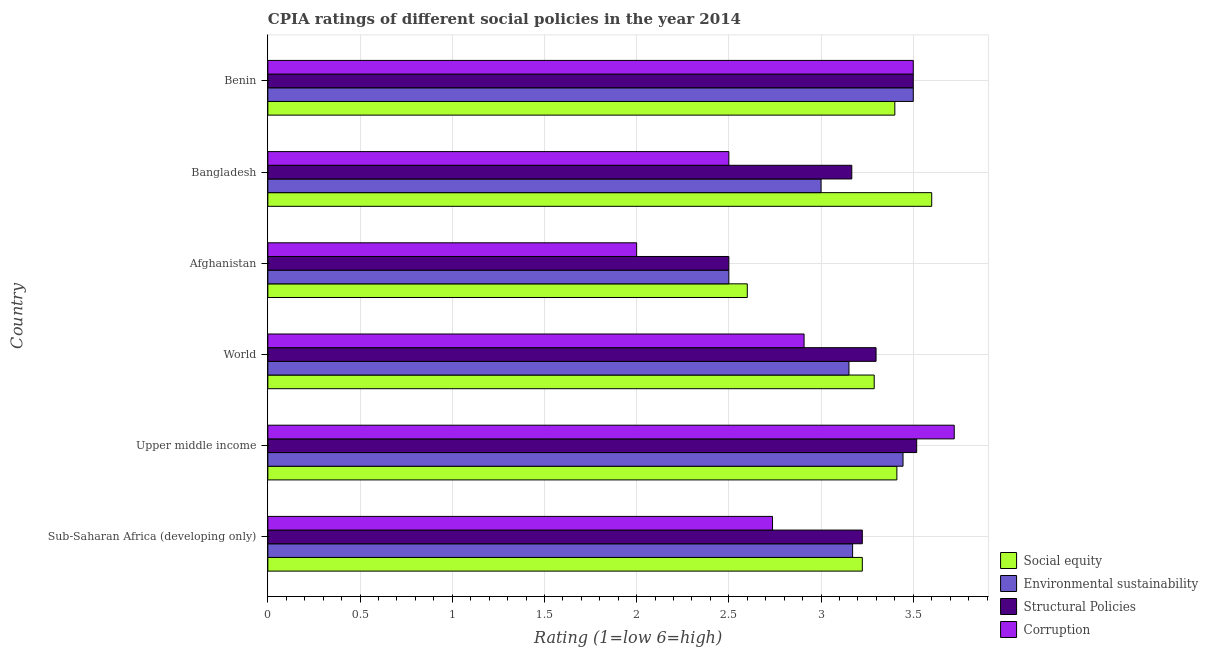How many different coloured bars are there?
Offer a very short reply. 4. What is the label of the 4th group of bars from the top?
Provide a short and direct response. World. What is the cpia rating of environmental sustainability in Sub-Saharan Africa (developing only)?
Make the answer very short. 3.17. Across all countries, what is the maximum cpia rating of social equity?
Keep it short and to the point. 3.6. In which country was the cpia rating of structural policies maximum?
Make the answer very short. Upper middle income. In which country was the cpia rating of social equity minimum?
Your answer should be compact. Afghanistan. What is the total cpia rating of structural policies in the graph?
Give a very brief answer. 19.21. What is the difference between the cpia rating of environmental sustainability in Afghanistan and that in Benin?
Your answer should be compact. -1. What is the difference between the cpia rating of environmental sustainability in World and the cpia rating of social equity in Sub-Saharan Africa (developing only)?
Keep it short and to the point. -0.07. What is the average cpia rating of structural policies per country?
Offer a very short reply. 3.2. What is the ratio of the cpia rating of environmental sustainability in Bangladesh to that in Upper middle income?
Your answer should be compact. 0.87. Is the cpia rating of environmental sustainability in Benin less than that in Upper middle income?
Give a very brief answer. No. What is the difference between the highest and the second highest cpia rating of environmental sustainability?
Offer a very short reply. 0.06. What is the difference between the highest and the lowest cpia rating of environmental sustainability?
Give a very brief answer. 1. In how many countries, is the cpia rating of environmental sustainability greater than the average cpia rating of environmental sustainability taken over all countries?
Make the answer very short. 4. Is it the case that in every country, the sum of the cpia rating of structural policies and cpia rating of corruption is greater than the sum of cpia rating of social equity and cpia rating of environmental sustainability?
Your answer should be very brief. No. What does the 4th bar from the top in Sub-Saharan Africa (developing only) represents?
Ensure brevity in your answer.  Social equity. What does the 2nd bar from the bottom in World represents?
Ensure brevity in your answer.  Environmental sustainability. Is it the case that in every country, the sum of the cpia rating of social equity and cpia rating of environmental sustainability is greater than the cpia rating of structural policies?
Keep it short and to the point. Yes. Does the graph contain any zero values?
Your answer should be compact. No. Where does the legend appear in the graph?
Your answer should be compact. Bottom right. How many legend labels are there?
Your answer should be very brief. 4. What is the title of the graph?
Give a very brief answer. CPIA ratings of different social policies in the year 2014. What is the Rating (1=low 6=high) of Social equity in Sub-Saharan Africa (developing only)?
Your response must be concise. 3.22. What is the Rating (1=low 6=high) in Environmental sustainability in Sub-Saharan Africa (developing only)?
Give a very brief answer. 3.17. What is the Rating (1=low 6=high) of Structural Policies in Sub-Saharan Africa (developing only)?
Your answer should be very brief. 3.22. What is the Rating (1=low 6=high) of Corruption in Sub-Saharan Africa (developing only)?
Ensure brevity in your answer.  2.74. What is the Rating (1=low 6=high) in Social equity in Upper middle income?
Your answer should be compact. 3.41. What is the Rating (1=low 6=high) of Environmental sustainability in Upper middle income?
Offer a very short reply. 3.44. What is the Rating (1=low 6=high) of Structural Policies in Upper middle income?
Offer a very short reply. 3.52. What is the Rating (1=low 6=high) of Corruption in Upper middle income?
Ensure brevity in your answer.  3.72. What is the Rating (1=low 6=high) of Social equity in World?
Your answer should be very brief. 3.29. What is the Rating (1=low 6=high) in Environmental sustainability in World?
Keep it short and to the point. 3.15. What is the Rating (1=low 6=high) of Structural Policies in World?
Provide a short and direct response. 3.3. What is the Rating (1=low 6=high) of Corruption in World?
Ensure brevity in your answer.  2.91. What is the Rating (1=low 6=high) of Social equity in Afghanistan?
Your answer should be compact. 2.6. What is the Rating (1=low 6=high) of Corruption in Afghanistan?
Provide a short and direct response. 2. What is the Rating (1=low 6=high) in Social equity in Bangladesh?
Your response must be concise. 3.6. What is the Rating (1=low 6=high) in Environmental sustainability in Bangladesh?
Your response must be concise. 3. What is the Rating (1=low 6=high) in Structural Policies in Bangladesh?
Provide a succinct answer. 3.17. What is the Rating (1=low 6=high) of Environmental sustainability in Benin?
Your response must be concise. 3.5. What is the Rating (1=low 6=high) of Structural Policies in Benin?
Your response must be concise. 3.5. What is the Rating (1=low 6=high) in Corruption in Benin?
Make the answer very short. 3.5. Across all countries, what is the maximum Rating (1=low 6=high) in Structural Policies?
Offer a terse response. 3.52. Across all countries, what is the maximum Rating (1=low 6=high) of Corruption?
Ensure brevity in your answer.  3.72. Across all countries, what is the minimum Rating (1=low 6=high) of Social equity?
Give a very brief answer. 2.6. Across all countries, what is the minimum Rating (1=low 6=high) in Environmental sustainability?
Give a very brief answer. 2.5. Across all countries, what is the minimum Rating (1=low 6=high) in Corruption?
Ensure brevity in your answer.  2. What is the total Rating (1=low 6=high) in Social equity in the graph?
Ensure brevity in your answer.  19.52. What is the total Rating (1=low 6=high) in Environmental sustainability in the graph?
Give a very brief answer. 18.77. What is the total Rating (1=low 6=high) of Structural Policies in the graph?
Your answer should be very brief. 19.21. What is the total Rating (1=low 6=high) in Corruption in the graph?
Give a very brief answer. 17.37. What is the difference between the Rating (1=low 6=high) of Social equity in Sub-Saharan Africa (developing only) and that in Upper middle income?
Your answer should be compact. -0.19. What is the difference between the Rating (1=low 6=high) of Environmental sustainability in Sub-Saharan Africa (developing only) and that in Upper middle income?
Your answer should be very brief. -0.27. What is the difference between the Rating (1=low 6=high) in Structural Policies in Sub-Saharan Africa (developing only) and that in Upper middle income?
Provide a short and direct response. -0.29. What is the difference between the Rating (1=low 6=high) in Corruption in Sub-Saharan Africa (developing only) and that in Upper middle income?
Keep it short and to the point. -0.99. What is the difference between the Rating (1=low 6=high) in Social equity in Sub-Saharan Africa (developing only) and that in World?
Provide a succinct answer. -0.06. What is the difference between the Rating (1=low 6=high) of Environmental sustainability in Sub-Saharan Africa (developing only) and that in World?
Your answer should be compact. 0.02. What is the difference between the Rating (1=low 6=high) of Structural Policies in Sub-Saharan Africa (developing only) and that in World?
Keep it short and to the point. -0.07. What is the difference between the Rating (1=low 6=high) of Corruption in Sub-Saharan Africa (developing only) and that in World?
Give a very brief answer. -0.17. What is the difference between the Rating (1=low 6=high) of Social equity in Sub-Saharan Africa (developing only) and that in Afghanistan?
Your answer should be compact. 0.62. What is the difference between the Rating (1=low 6=high) in Environmental sustainability in Sub-Saharan Africa (developing only) and that in Afghanistan?
Offer a terse response. 0.67. What is the difference between the Rating (1=low 6=high) of Structural Policies in Sub-Saharan Africa (developing only) and that in Afghanistan?
Give a very brief answer. 0.72. What is the difference between the Rating (1=low 6=high) of Corruption in Sub-Saharan Africa (developing only) and that in Afghanistan?
Ensure brevity in your answer.  0.74. What is the difference between the Rating (1=low 6=high) in Social equity in Sub-Saharan Africa (developing only) and that in Bangladesh?
Make the answer very short. -0.38. What is the difference between the Rating (1=low 6=high) of Environmental sustainability in Sub-Saharan Africa (developing only) and that in Bangladesh?
Your response must be concise. 0.17. What is the difference between the Rating (1=low 6=high) of Structural Policies in Sub-Saharan Africa (developing only) and that in Bangladesh?
Your answer should be very brief. 0.06. What is the difference between the Rating (1=low 6=high) in Corruption in Sub-Saharan Africa (developing only) and that in Bangladesh?
Provide a succinct answer. 0.24. What is the difference between the Rating (1=low 6=high) in Social equity in Sub-Saharan Africa (developing only) and that in Benin?
Your answer should be compact. -0.18. What is the difference between the Rating (1=low 6=high) of Environmental sustainability in Sub-Saharan Africa (developing only) and that in Benin?
Your response must be concise. -0.33. What is the difference between the Rating (1=low 6=high) in Structural Policies in Sub-Saharan Africa (developing only) and that in Benin?
Your answer should be very brief. -0.28. What is the difference between the Rating (1=low 6=high) in Corruption in Sub-Saharan Africa (developing only) and that in Benin?
Your response must be concise. -0.76. What is the difference between the Rating (1=low 6=high) of Social equity in Upper middle income and that in World?
Provide a succinct answer. 0.12. What is the difference between the Rating (1=low 6=high) in Environmental sustainability in Upper middle income and that in World?
Offer a very short reply. 0.29. What is the difference between the Rating (1=low 6=high) of Structural Policies in Upper middle income and that in World?
Offer a very short reply. 0.22. What is the difference between the Rating (1=low 6=high) of Corruption in Upper middle income and that in World?
Your answer should be compact. 0.81. What is the difference between the Rating (1=low 6=high) of Social equity in Upper middle income and that in Afghanistan?
Keep it short and to the point. 0.81. What is the difference between the Rating (1=low 6=high) in Environmental sustainability in Upper middle income and that in Afghanistan?
Ensure brevity in your answer.  0.94. What is the difference between the Rating (1=low 6=high) in Structural Policies in Upper middle income and that in Afghanistan?
Keep it short and to the point. 1.02. What is the difference between the Rating (1=low 6=high) of Corruption in Upper middle income and that in Afghanistan?
Give a very brief answer. 1.72. What is the difference between the Rating (1=low 6=high) of Social equity in Upper middle income and that in Bangladesh?
Your answer should be compact. -0.19. What is the difference between the Rating (1=low 6=high) in Environmental sustainability in Upper middle income and that in Bangladesh?
Offer a terse response. 0.44. What is the difference between the Rating (1=low 6=high) of Structural Policies in Upper middle income and that in Bangladesh?
Offer a terse response. 0.35. What is the difference between the Rating (1=low 6=high) of Corruption in Upper middle income and that in Bangladesh?
Your answer should be compact. 1.22. What is the difference between the Rating (1=low 6=high) of Social equity in Upper middle income and that in Benin?
Keep it short and to the point. 0.01. What is the difference between the Rating (1=low 6=high) in Environmental sustainability in Upper middle income and that in Benin?
Provide a succinct answer. -0.06. What is the difference between the Rating (1=low 6=high) of Structural Policies in Upper middle income and that in Benin?
Provide a short and direct response. 0.02. What is the difference between the Rating (1=low 6=high) of Corruption in Upper middle income and that in Benin?
Your answer should be compact. 0.22. What is the difference between the Rating (1=low 6=high) of Social equity in World and that in Afghanistan?
Your answer should be compact. 0.69. What is the difference between the Rating (1=low 6=high) of Environmental sustainability in World and that in Afghanistan?
Offer a terse response. 0.65. What is the difference between the Rating (1=low 6=high) in Structural Policies in World and that in Afghanistan?
Offer a very short reply. 0.8. What is the difference between the Rating (1=low 6=high) in Corruption in World and that in Afghanistan?
Make the answer very short. 0.91. What is the difference between the Rating (1=low 6=high) in Social equity in World and that in Bangladesh?
Make the answer very short. -0.31. What is the difference between the Rating (1=low 6=high) of Environmental sustainability in World and that in Bangladesh?
Make the answer very short. 0.15. What is the difference between the Rating (1=low 6=high) in Structural Policies in World and that in Bangladesh?
Ensure brevity in your answer.  0.13. What is the difference between the Rating (1=low 6=high) of Corruption in World and that in Bangladesh?
Ensure brevity in your answer.  0.41. What is the difference between the Rating (1=low 6=high) of Social equity in World and that in Benin?
Offer a very short reply. -0.11. What is the difference between the Rating (1=low 6=high) in Environmental sustainability in World and that in Benin?
Keep it short and to the point. -0.35. What is the difference between the Rating (1=low 6=high) in Structural Policies in World and that in Benin?
Your response must be concise. -0.2. What is the difference between the Rating (1=low 6=high) of Corruption in World and that in Benin?
Your response must be concise. -0.59. What is the difference between the Rating (1=low 6=high) in Social equity in Afghanistan and that in Bangladesh?
Offer a terse response. -1. What is the difference between the Rating (1=low 6=high) of Corruption in Afghanistan and that in Bangladesh?
Provide a short and direct response. -0.5. What is the difference between the Rating (1=low 6=high) of Social equity in Afghanistan and that in Benin?
Offer a very short reply. -0.8. What is the difference between the Rating (1=low 6=high) of Social equity in Bangladesh and that in Benin?
Provide a succinct answer. 0.2. What is the difference between the Rating (1=low 6=high) in Environmental sustainability in Bangladesh and that in Benin?
Your answer should be compact. -0.5. What is the difference between the Rating (1=low 6=high) in Corruption in Bangladesh and that in Benin?
Provide a succinct answer. -1. What is the difference between the Rating (1=low 6=high) in Social equity in Sub-Saharan Africa (developing only) and the Rating (1=low 6=high) in Environmental sustainability in Upper middle income?
Offer a terse response. -0.22. What is the difference between the Rating (1=low 6=high) of Social equity in Sub-Saharan Africa (developing only) and the Rating (1=low 6=high) of Structural Policies in Upper middle income?
Make the answer very short. -0.29. What is the difference between the Rating (1=low 6=high) of Social equity in Sub-Saharan Africa (developing only) and the Rating (1=low 6=high) of Corruption in Upper middle income?
Offer a terse response. -0.5. What is the difference between the Rating (1=low 6=high) of Environmental sustainability in Sub-Saharan Africa (developing only) and the Rating (1=low 6=high) of Structural Policies in Upper middle income?
Ensure brevity in your answer.  -0.35. What is the difference between the Rating (1=low 6=high) of Environmental sustainability in Sub-Saharan Africa (developing only) and the Rating (1=low 6=high) of Corruption in Upper middle income?
Your response must be concise. -0.55. What is the difference between the Rating (1=low 6=high) in Structural Policies in Sub-Saharan Africa (developing only) and the Rating (1=low 6=high) in Corruption in Upper middle income?
Your answer should be very brief. -0.5. What is the difference between the Rating (1=low 6=high) of Social equity in Sub-Saharan Africa (developing only) and the Rating (1=low 6=high) of Environmental sustainability in World?
Offer a very short reply. 0.07. What is the difference between the Rating (1=low 6=high) in Social equity in Sub-Saharan Africa (developing only) and the Rating (1=low 6=high) in Structural Policies in World?
Your answer should be compact. -0.07. What is the difference between the Rating (1=low 6=high) of Social equity in Sub-Saharan Africa (developing only) and the Rating (1=low 6=high) of Corruption in World?
Your answer should be compact. 0.32. What is the difference between the Rating (1=low 6=high) of Environmental sustainability in Sub-Saharan Africa (developing only) and the Rating (1=low 6=high) of Structural Policies in World?
Provide a succinct answer. -0.13. What is the difference between the Rating (1=low 6=high) in Environmental sustainability in Sub-Saharan Africa (developing only) and the Rating (1=low 6=high) in Corruption in World?
Provide a succinct answer. 0.26. What is the difference between the Rating (1=low 6=high) of Structural Policies in Sub-Saharan Africa (developing only) and the Rating (1=low 6=high) of Corruption in World?
Your response must be concise. 0.32. What is the difference between the Rating (1=low 6=high) of Social equity in Sub-Saharan Africa (developing only) and the Rating (1=low 6=high) of Environmental sustainability in Afghanistan?
Ensure brevity in your answer.  0.72. What is the difference between the Rating (1=low 6=high) in Social equity in Sub-Saharan Africa (developing only) and the Rating (1=low 6=high) in Structural Policies in Afghanistan?
Your response must be concise. 0.72. What is the difference between the Rating (1=low 6=high) of Social equity in Sub-Saharan Africa (developing only) and the Rating (1=low 6=high) of Corruption in Afghanistan?
Give a very brief answer. 1.22. What is the difference between the Rating (1=low 6=high) of Environmental sustainability in Sub-Saharan Africa (developing only) and the Rating (1=low 6=high) of Structural Policies in Afghanistan?
Offer a very short reply. 0.67. What is the difference between the Rating (1=low 6=high) in Environmental sustainability in Sub-Saharan Africa (developing only) and the Rating (1=low 6=high) in Corruption in Afghanistan?
Keep it short and to the point. 1.17. What is the difference between the Rating (1=low 6=high) in Structural Policies in Sub-Saharan Africa (developing only) and the Rating (1=low 6=high) in Corruption in Afghanistan?
Your answer should be compact. 1.22. What is the difference between the Rating (1=low 6=high) of Social equity in Sub-Saharan Africa (developing only) and the Rating (1=low 6=high) of Environmental sustainability in Bangladesh?
Keep it short and to the point. 0.22. What is the difference between the Rating (1=low 6=high) of Social equity in Sub-Saharan Africa (developing only) and the Rating (1=low 6=high) of Structural Policies in Bangladesh?
Your answer should be very brief. 0.06. What is the difference between the Rating (1=low 6=high) of Social equity in Sub-Saharan Africa (developing only) and the Rating (1=low 6=high) of Corruption in Bangladesh?
Your response must be concise. 0.72. What is the difference between the Rating (1=low 6=high) in Environmental sustainability in Sub-Saharan Africa (developing only) and the Rating (1=low 6=high) in Structural Policies in Bangladesh?
Give a very brief answer. 0. What is the difference between the Rating (1=low 6=high) in Environmental sustainability in Sub-Saharan Africa (developing only) and the Rating (1=low 6=high) in Corruption in Bangladesh?
Provide a short and direct response. 0.67. What is the difference between the Rating (1=low 6=high) of Structural Policies in Sub-Saharan Africa (developing only) and the Rating (1=low 6=high) of Corruption in Bangladesh?
Offer a very short reply. 0.72. What is the difference between the Rating (1=low 6=high) in Social equity in Sub-Saharan Africa (developing only) and the Rating (1=low 6=high) in Environmental sustainability in Benin?
Offer a very short reply. -0.28. What is the difference between the Rating (1=low 6=high) in Social equity in Sub-Saharan Africa (developing only) and the Rating (1=low 6=high) in Structural Policies in Benin?
Your answer should be compact. -0.28. What is the difference between the Rating (1=low 6=high) in Social equity in Sub-Saharan Africa (developing only) and the Rating (1=low 6=high) in Corruption in Benin?
Your response must be concise. -0.28. What is the difference between the Rating (1=low 6=high) of Environmental sustainability in Sub-Saharan Africa (developing only) and the Rating (1=low 6=high) of Structural Policies in Benin?
Your answer should be compact. -0.33. What is the difference between the Rating (1=low 6=high) in Environmental sustainability in Sub-Saharan Africa (developing only) and the Rating (1=low 6=high) in Corruption in Benin?
Provide a short and direct response. -0.33. What is the difference between the Rating (1=low 6=high) in Structural Policies in Sub-Saharan Africa (developing only) and the Rating (1=low 6=high) in Corruption in Benin?
Provide a short and direct response. -0.28. What is the difference between the Rating (1=low 6=high) of Social equity in Upper middle income and the Rating (1=low 6=high) of Environmental sustainability in World?
Your answer should be compact. 0.26. What is the difference between the Rating (1=low 6=high) of Social equity in Upper middle income and the Rating (1=low 6=high) of Structural Policies in World?
Your response must be concise. 0.11. What is the difference between the Rating (1=low 6=high) of Social equity in Upper middle income and the Rating (1=low 6=high) of Corruption in World?
Offer a terse response. 0.5. What is the difference between the Rating (1=low 6=high) of Environmental sustainability in Upper middle income and the Rating (1=low 6=high) of Structural Policies in World?
Ensure brevity in your answer.  0.15. What is the difference between the Rating (1=low 6=high) in Environmental sustainability in Upper middle income and the Rating (1=low 6=high) in Corruption in World?
Your answer should be compact. 0.54. What is the difference between the Rating (1=low 6=high) in Structural Policies in Upper middle income and the Rating (1=low 6=high) in Corruption in World?
Your response must be concise. 0.61. What is the difference between the Rating (1=low 6=high) in Social equity in Upper middle income and the Rating (1=low 6=high) in Environmental sustainability in Afghanistan?
Provide a succinct answer. 0.91. What is the difference between the Rating (1=low 6=high) in Social equity in Upper middle income and the Rating (1=low 6=high) in Structural Policies in Afghanistan?
Keep it short and to the point. 0.91. What is the difference between the Rating (1=low 6=high) in Social equity in Upper middle income and the Rating (1=low 6=high) in Corruption in Afghanistan?
Keep it short and to the point. 1.41. What is the difference between the Rating (1=low 6=high) in Environmental sustainability in Upper middle income and the Rating (1=low 6=high) in Corruption in Afghanistan?
Your answer should be compact. 1.44. What is the difference between the Rating (1=low 6=high) of Structural Policies in Upper middle income and the Rating (1=low 6=high) of Corruption in Afghanistan?
Keep it short and to the point. 1.52. What is the difference between the Rating (1=low 6=high) of Social equity in Upper middle income and the Rating (1=low 6=high) of Environmental sustainability in Bangladesh?
Your answer should be compact. 0.41. What is the difference between the Rating (1=low 6=high) in Social equity in Upper middle income and the Rating (1=low 6=high) in Structural Policies in Bangladesh?
Make the answer very short. 0.24. What is the difference between the Rating (1=low 6=high) of Social equity in Upper middle income and the Rating (1=low 6=high) of Corruption in Bangladesh?
Your answer should be very brief. 0.91. What is the difference between the Rating (1=low 6=high) of Environmental sustainability in Upper middle income and the Rating (1=low 6=high) of Structural Policies in Bangladesh?
Your answer should be very brief. 0.28. What is the difference between the Rating (1=low 6=high) of Structural Policies in Upper middle income and the Rating (1=low 6=high) of Corruption in Bangladesh?
Provide a short and direct response. 1.02. What is the difference between the Rating (1=low 6=high) of Social equity in Upper middle income and the Rating (1=low 6=high) of Environmental sustainability in Benin?
Offer a very short reply. -0.09. What is the difference between the Rating (1=low 6=high) of Social equity in Upper middle income and the Rating (1=low 6=high) of Structural Policies in Benin?
Provide a short and direct response. -0.09. What is the difference between the Rating (1=low 6=high) in Social equity in Upper middle income and the Rating (1=low 6=high) in Corruption in Benin?
Offer a terse response. -0.09. What is the difference between the Rating (1=low 6=high) in Environmental sustainability in Upper middle income and the Rating (1=low 6=high) in Structural Policies in Benin?
Keep it short and to the point. -0.06. What is the difference between the Rating (1=low 6=high) in Environmental sustainability in Upper middle income and the Rating (1=low 6=high) in Corruption in Benin?
Your answer should be compact. -0.06. What is the difference between the Rating (1=low 6=high) in Structural Policies in Upper middle income and the Rating (1=low 6=high) in Corruption in Benin?
Ensure brevity in your answer.  0.02. What is the difference between the Rating (1=low 6=high) in Social equity in World and the Rating (1=low 6=high) in Environmental sustainability in Afghanistan?
Ensure brevity in your answer.  0.79. What is the difference between the Rating (1=low 6=high) of Social equity in World and the Rating (1=low 6=high) of Structural Policies in Afghanistan?
Your answer should be very brief. 0.79. What is the difference between the Rating (1=low 6=high) in Social equity in World and the Rating (1=low 6=high) in Corruption in Afghanistan?
Offer a very short reply. 1.29. What is the difference between the Rating (1=low 6=high) in Environmental sustainability in World and the Rating (1=low 6=high) in Structural Policies in Afghanistan?
Provide a succinct answer. 0.65. What is the difference between the Rating (1=low 6=high) in Environmental sustainability in World and the Rating (1=low 6=high) in Corruption in Afghanistan?
Your answer should be compact. 1.15. What is the difference between the Rating (1=low 6=high) of Structural Policies in World and the Rating (1=low 6=high) of Corruption in Afghanistan?
Your answer should be compact. 1.3. What is the difference between the Rating (1=low 6=high) in Social equity in World and the Rating (1=low 6=high) in Environmental sustainability in Bangladesh?
Make the answer very short. 0.29. What is the difference between the Rating (1=low 6=high) of Social equity in World and the Rating (1=low 6=high) of Structural Policies in Bangladesh?
Offer a terse response. 0.12. What is the difference between the Rating (1=low 6=high) of Social equity in World and the Rating (1=low 6=high) of Corruption in Bangladesh?
Offer a very short reply. 0.79. What is the difference between the Rating (1=low 6=high) in Environmental sustainability in World and the Rating (1=low 6=high) in Structural Policies in Bangladesh?
Provide a short and direct response. -0.02. What is the difference between the Rating (1=low 6=high) of Environmental sustainability in World and the Rating (1=low 6=high) of Corruption in Bangladesh?
Make the answer very short. 0.65. What is the difference between the Rating (1=low 6=high) in Structural Policies in World and the Rating (1=low 6=high) in Corruption in Bangladesh?
Your response must be concise. 0.8. What is the difference between the Rating (1=low 6=high) of Social equity in World and the Rating (1=low 6=high) of Environmental sustainability in Benin?
Give a very brief answer. -0.21. What is the difference between the Rating (1=low 6=high) of Social equity in World and the Rating (1=low 6=high) of Structural Policies in Benin?
Your answer should be compact. -0.21. What is the difference between the Rating (1=low 6=high) of Social equity in World and the Rating (1=low 6=high) of Corruption in Benin?
Keep it short and to the point. -0.21. What is the difference between the Rating (1=low 6=high) in Environmental sustainability in World and the Rating (1=low 6=high) in Structural Policies in Benin?
Keep it short and to the point. -0.35. What is the difference between the Rating (1=low 6=high) in Environmental sustainability in World and the Rating (1=low 6=high) in Corruption in Benin?
Provide a succinct answer. -0.35. What is the difference between the Rating (1=low 6=high) of Structural Policies in World and the Rating (1=low 6=high) of Corruption in Benin?
Keep it short and to the point. -0.2. What is the difference between the Rating (1=low 6=high) of Social equity in Afghanistan and the Rating (1=low 6=high) of Environmental sustainability in Bangladesh?
Your response must be concise. -0.4. What is the difference between the Rating (1=low 6=high) in Social equity in Afghanistan and the Rating (1=low 6=high) in Structural Policies in Bangladesh?
Give a very brief answer. -0.57. What is the difference between the Rating (1=low 6=high) of Environmental sustainability in Afghanistan and the Rating (1=low 6=high) of Structural Policies in Bangladesh?
Ensure brevity in your answer.  -0.67. What is the difference between the Rating (1=low 6=high) of Social equity in Afghanistan and the Rating (1=low 6=high) of Corruption in Benin?
Your answer should be compact. -0.9. What is the difference between the Rating (1=low 6=high) of Environmental sustainability in Afghanistan and the Rating (1=low 6=high) of Structural Policies in Benin?
Offer a very short reply. -1. What is the difference between the Rating (1=low 6=high) in Structural Policies in Afghanistan and the Rating (1=low 6=high) in Corruption in Benin?
Make the answer very short. -1. What is the difference between the Rating (1=low 6=high) in Social equity in Bangladesh and the Rating (1=low 6=high) in Environmental sustainability in Benin?
Keep it short and to the point. 0.1. What is the difference between the Rating (1=low 6=high) in Environmental sustainability in Bangladesh and the Rating (1=low 6=high) in Corruption in Benin?
Provide a short and direct response. -0.5. What is the difference between the Rating (1=low 6=high) of Structural Policies in Bangladesh and the Rating (1=low 6=high) of Corruption in Benin?
Provide a succinct answer. -0.33. What is the average Rating (1=low 6=high) of Social equity per country?
Provide a succinct answer. 3.25. What is the average Rating (1=low 6=high) of Environmental sustainability per country?
Offer a very short reply. 3.13. What is the average Rating (1=low 6=high) of Structural Policies per country?
Your response must be concise. 3.2. What is the average Rating (1=low 6=high) in Corruption per country?
Offer a very short reply. 2.89. What is the difference between the Rating (1=low 6=high) of Social equity and Rating (1=low 6=high) of Environmental sustainability in Sub-Saharan Africa (developing only)?
Make the answer very short. 0.05. What is the difference between the Rating (1=low 6=high) in Social equity and Rating (1=low 6=high) in Corruption in Sub-Saharan Africa (developing only)?
Offer a very short reply. 0.49. What is the difference between the Rating (1=low 6=high) in Environmental sustainability and Rating (1=low 6=high) in Structural Policies in Sub-Saharan Africa (developing only)?
Ensure brevity in your answer.  -0.05. What is the difference between the Rating (1=low 6=high) of Environmental sustainability and Rating (1=low 6=high) of Corruption in Sub-Saharan Africa (developing only)?
Ensure brevity in your answer.  0.43. What is the difference between the Rating (1=low 6=high) of Structural Policies and Rating (1=low 6=high) of Corruption in Sub-Saharan Africa (developing only)?
Make the answer very short. 0.49. What is the difference between the Rating (1=low 6=high) of Social equity and Rating (1=low 6=high) of Environmental sustainability in Upper middle income?
Offer a terse response. -0.03. What is the difference between the Rating (1=low 6=high) of Social equity and Rating (1=low 6=high) of Structural Policies in Upper middle income?
Ensure brevity in your answer.  -0.11. What is the difference between the Rating (1=low 6=high) of Social equity and Rating (1=low 6=high) of Corruption in Upper middle income?
Provide a succinct answer. -0.31. What is the difference between the Rating (1=low 6=high) in Environmental sustainability and Rating (1=low 6=high) in Structural Policies in Upper middle income?
Your answer should be compact. -0.07. What is the difference between the Rating (1=low 6=high) in Environmental sustainability and Rating (1=low 6=high) in Corruption in Upper middle income?
Keep it short and to the point. -0.28. What is the difference between the Rating (1=low 6=high) of Structural Policies and Rating (1=low 6=high) of Corruption in Upper middle income?
Keep it short and to the point. -0.2. What is the difference between the Rating (1=low 6=high) of Social equity and Rating (1=low 6=high) of Environmental sustainability in World?
Give a very brief answer. 0.14. What is the difference between the Rating (1=low 6=high) of Social equity and Rating (1=low 6=high) of Structural Policies in World?
Give a very brief answer. -0.01. What is the difference between the Rating (1=low 6=high) in Social equity and Rating (1=low 6=high) in Corruption in World?
Provide a succinct answer. 0.38. What is the difference between the Rating (1=low 6=high) in Environmental sustainability and Rating (1=low 6=high) in Structural Policies in World?
Your response must be concise. -0.15. What is the difference between the Rating (1=low 6=high) in Environmental sustainability and Rating (1=low 6=high) in Corruption in World?
Provide a short and direct response. 0.24. What is the difference between the Rating (1=low 6=high) in Structural Policies and Rating (1=low 6=high) in Corruption in World?
Offer a terse response. 0.39. What is the difference between the Rating (1=low 6=high) in Social equity and Rating (1=low 6=high) in Structural Policies in Afghanistan?
Ensure brevity in your answer.  0.1. What is the difference between the Rating (1=low 6=high) in Social equity and Rating (1=low 6=high) in Corruption in Afghanistan?
Offer a very short reply. 0.6. What is the difference between the Rating (1=low 6=high) in Environmental sustainability and Rating (1=low 6=high) in Structural Policies in Afghanistan?
Offer a very short reply. 0. What is the difference between the Rating (1=low 6=high) of Social equity and Rating (1=low 6=high) of Environmental sustainability in Bangladesh?
Offer a terse response. 0.6. What is the difference between the Rating (1=low 6=high) in Social equity and Rating (1=low 6=high) in Structural Policies in Bangladesh?
Provide a succinct answer. 0.43. What is the difference between the Rating (1=low 6=high) in Social equity and Rating (1=low 6=high) in Corruption in Bangladesh?
Give a very brief answer. 1.1. What is the difference between the Rating (1=low 6=high) of Environmental sustainability and Rating (1=low 6=high) of Structural Policies in Bangladesh?
Your answer should be very brief. -0.17. What is the difference between the Rating (1=low 6=high) in Environmental sustainability and Rating (1=low 6=high) in Corruption in Bangladesh?
Ensure brevity in your answer.  0.5. What is the difference between the Rating (1=low 6=high) in Social equity and Rating (1=low 6=high) in Environmental sustainability in Benin?
Give a very brief answer. -0.1. What is the difference between the Rating (1=low 6=high) in Social equity and Rating (1=low 6=high) in Corruption in Benin?
Ensure brevity in your answer.  -0.1. What is the difference between the Rating (1=low 6=high) in Environmental sustainability and Rating (1=low 6=high) in Structural Policies in Benin?
Offer a very short reply. 0. What is the difference between the Rating (1=low 6=high) of Structural Policies and Rating (1=low 6=high) of Corruption in Benin?
Make the answer very short. 0. What is the ratio of the Rating (1=low 6=high) of Social equity in Sub-Saharan Africa (developing only) to that in Upper middle income?
Your answer should be compact. 0.95. What is the ratio of the Rating (1=low 6=high) in Environmental sustainability in Sub-Saharan Africa (developing only) to that in Upper middle income?
Offer a very short reply. 0.92. What is the ratio of the Rating (1=low 6=high) in Structural Policies in Sub-Saharan Africa (developing only) to that in Upper middle income?
Give a very brief answer. 0.92. What is the ratio of the Rating (1=low 6=high) of Corruption in Sub-Saharan Africa (developing only) to that in Upper middle income?
Ensure brevity in your answer.  0.74. What is the ratio of the Rating (1=low 6=high) of Social equity in Sub-Saharan Africa (developing only) to that in World?
Provide a short and direct response. 0.98. What is the ratio of the Rating (1=low 6=high) of Structural Policies in Sub-Saharan Africa (developing only) to that in World?
Your response must be concise. 0.98. What is the ratio of the Rating (1=low 6=high) in Corruption in Sub-Saharan Africa (developing only) to that in World?
Make the answer very short. 0.94. What is the ratio of the Rating (1=low 6=high) of Social equity in Sub-Saharan Africa (developing only) to that in Afghanistan?
Your response must be concise. 1.24. What is the ratio of the Rating (1=low 6=high) in Environmental sustainability in Sub-Saharan Africa (developing only) to that in Afghanistan?
Provide a succinct answer. 1.27. What is the ratio of the Rating (1=low 6=high) in Structural Policies in Sub-Saharan Africa (developing only) to that in Afghanistan?
Keep it short and to the point. 1.29. What is the ratio of the Rating (1=low 6=high) in Corruption in Sub-Saharan Africa (developing only) to that in Afghanistan?
Offer a terse response. 1.37. What is the ratio of the Rating (1=low 6=high) in Social equity in Sub-Saharan Africa (developing only) to that in Bangladesh?
Provide a succinct answer. 0.9. What is the ratio of the Rating (1=low 6=high) in Environmental sustainability in Sub-Saharan Africa (developing only) to that in Bangladesh?
Ensure brevity in your answer.  1.06. What is the ratio of the Rating (1=low 6=high) of Corruption in Sub-Saharan Africa (developing only) to that in Bangladesh?
Provide a short and direct response. 1.09. What is the ratio of the Rating (1=low 6=high) in Social equity in Sub-Saharan Africa (developing only) to that in Benin?
Provide a short and direct response. 0.95. What is the ratio of the Rating (1=low 6=high) in Environmental sustainability in Sub-Saharan Africa (developing only) to that in Benin?
Your answer should be very brief. 0.91. What is the ratio of the Rating (1=low 6=high) of Structural Policies in Sub-Saharan Africa (developing only) to that in Benin?
Ensure brevity in your answer.  0.92. What is the ratio of the Rating (1=low 6=high) in Corruption in Sub-Saharan Africa (developing only) to that in Benin?
Your response must be concise. 0.78. What is the ratio of the Rating (1=low 6=high) of Social equity in Upper middle income to that in World?
Your answer should be compact. 1.04. What is the ratio of the Rating (1=low 6=high) of Environmental sustainability in Upper middle income to that in World?
Make the answer very short. 1.09. What is the ratio of the Rating (1=low 6=high) of Structural Policies in Upper middle income to that in World?
Give a very brief answer. 1.07. What is the ratio of the Rating (1=low 6=high) of Corruption in Upper middle income to that in World?
Ensure brevity in your answer.  1.28. What is the ratio of the Rating (1=low 6=high) in Social equity in Upper middle income to that in Afghanistan?
Your answer should be compact. 1.31. What is the ratio of the Rating (1=low 6=high) in Environmental sustainability in Upper middle income to that in Afghanistan?
Make the answer very short. 1.38. What is the ratio of the Rating (1=low 6=high) in Structural Policies in Upper middle income to that in Afghanistan?
Offer a terse response. 1.41. What is the ratio of the Rating (1=low 6=high) in Corruption in Upper middle income to that in Afghanistan?
Keep it short and to the point. 1.86. What is the ratio of the Rating (1=low 6=high) of Social equity in Upper middle income to that in Bangladesh?
Keep it short and to the point. 0.95. What is the ratio of the Rating (1=low 6=high) in Environmental sustainability in Upper middle income to that in Bangladesh?
Your answer should be compact. 1.15. What is the ratio of the Rating (1=low 6=high) in Structural Policies in Upper middle income to that in Bangladesh?
Your response must be concise. 1.11. What is the ratio of the Rating (1=low 6=high) in Corruption in Upper middle income to that in Bangladesh?
Keep it short and to the point. 1.49. What is the ratio of the Rating (1=low 6=high) of Social equity in Upper middle income to that in Benin?
Ensure brevity in your answer.  1. What is the ratio of the Rating (1=low 6=high) in Environmental sustainability in Upper middle income to that in Benin?
Make the answer very short. 0.98. What is the ratio of the Rating (1=low 6=high) of Structural Policies in Upper middle income to that in Benin?
Ensure brevity in your answer.  1.01. What is the ratio of the Rating (1=low 6=high) of Corruption in Upper middle income to that in Benin?
Your answer should be very brief. 1.06. What is the ratio of the Rating (1=low 6=high) of Social equity in World to that in Afghanistan?
Provide a succinct answer. 1.26. What is the ratio of the Rating (1=low 6=high) in Environmental sustainability in World to that in Afghanistan?
Make the answer very short. 1.26. What is the ratio of the Rating (1=low 6=high) of Structural Policies in World to that in Afghanistan?
Your answer should be compact. 1.32. What is the ratio of the Rating (1=low 6=high) in Corruption in World to that in Afghanistan?
Ensure brevity in your answer.  1.45. What is the ratio of the Rating (1=low 6=high) in Social equity in World to that in Bangladesh?
Ensure brevity in your answer.  0.91. What is the ratio of the Rating (1=low 6=high) of Environmental sustainability in World to that in Bangladesh?
Make the answer very short. 1.05. What is the ratio of the Rating (1=low 6=high) of Structural Policies in World to that in Bangladesh?
Give a very brief answer. 1.04. What is the ratio of the Rating (1=low 6=high) in Corruption in World to that in Bangladesh?
Keep it short and to the point. 1.16. What is the ratio of the Rating (1=low 6=high) of Social equity in World to that in Benin?
Give a very brief answer. 0.97. What is the ratio of the Rating (1=low 6=high) in Environmental sustainability in World to that in Benin?
Provide a short and direct response. 0.9. What is the ratio of the Rating (1=low 6=high) of Structural Policies in World to that in Benin?
Ensure brevity in your answer.  0.94. What is the ratio of the Rating (1=low 6=high) in Corruption in World to that in Benin?
Provide a short and direct response. 0.83. What is the ratio of the Rating (1=low 6=high) in Social equity in Afghanistan to that in Bangladesh?
Your answer should be very brief. 0.72. What is the ratio of the Rating (1=low 6=high) in Structural Policies in Afghanistan to that in Bangladesh?
Provide a succinct answer. 0.79. What is the ratio of the Rating (1=low 6=high) of Social equity in Afghanistan to that in Benin?
Your answer should be compact. 0.76. What is the ratio of the Rating (1=low 6=high) in Environmental sustainability in Afghanistan to that in Benin?
Ensure brevity in your answer.  0.71. What is the ratio of the Rating (1=low 6=high) of Structural Policies in Afghanistan to that in Benin?
Keep it short and to the point. 0.71. What is the ratio of the Rating (1=low 6=high) of Corruption in Afghanistan to that in Benin?
Keep it short and to the point. 0.57. What is the ratio of the Rating (1=low 6=high) in Social equity in Bangladesh to that in Benin?
Offer a terse response. 1.06. What is the ratio of the Rating (1=low 6=high) in Structural Policies in Bangladesh to that in Benin?
Your answer should be compact. 0.9. What is the ratio of the Rating (1=low 6=high) in Corruption in Bangladesh to that in Benin?
Ensure brevity in your answer.  0.71. What is the difference between the highest and the second highest Rating (1=low 6=high) of Social equity?
Ensure brevity in your answer.  0.19. What is the difference between the highest and the second highest Rating (1=low 6=high) in Environmental sustainability?
Provide a succinct answer. 0.06. What is the difference between the highest and the second highest Rating (1=low 6=high) in Structural Policies?
Offer a very short reply. 0.02. What is the difference between the highest and the second highest Rating (1=low 6=high) in Corruption?
Provide a short and direct response. 0.22. What is the difference between the highest and the lowest Rating (1=low 6=high) in Environmental sustainability?
Make the answer very short. 1. What is the difference between the highest and the lowest Rating (1=low 6=high) in Structural Policies?
Offer a very short reply. 1.02. What is the difference between the highest and the lowest Rating (1=low 6=high) of Corruption?
Your answer should be compact. 1.72. 